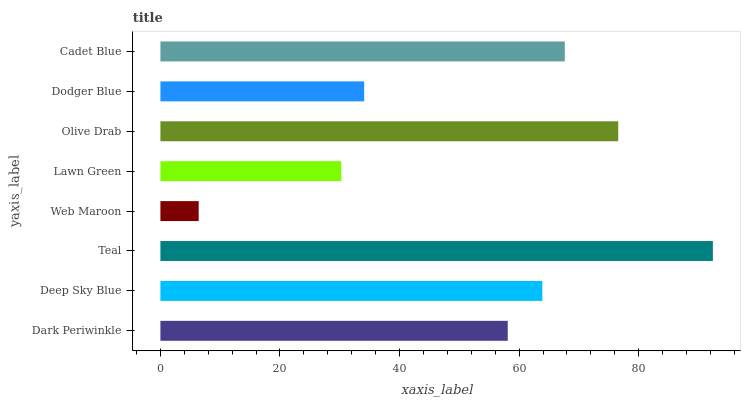Is Web Maroon the minimum?
Answer yes or no. Yes. Is Teal the maximum?
Answer yes or no. Yes. Is Deep Sky Blue the minimum?
Answer yes or no. No. Is Deep Sky Blue the maximum?
Answer yes or no. No. Is Deep Sky Blue greater than Dark Periwinkle?
Answer yes or no. Yes. Is Dark Periwinkle less than Deep Sky Blue?
Answer yes or no. Yes. Is Dark Periwinkle greater than Deep Sky Blue?
Answer yes or no. No. Is Deep Sky Blue less than Dark Periwinkle?
Answer yes or no. No. Is Deep Sky Blue the high median?
Answer yes or no. Yes. Is Dark Periwinkle the low median?
Answer yes or no. Yes. Is Cadet Blue the high median?
Answer yes or no. No. Is Web Maroon the low median?
Answer yes or no. No. 